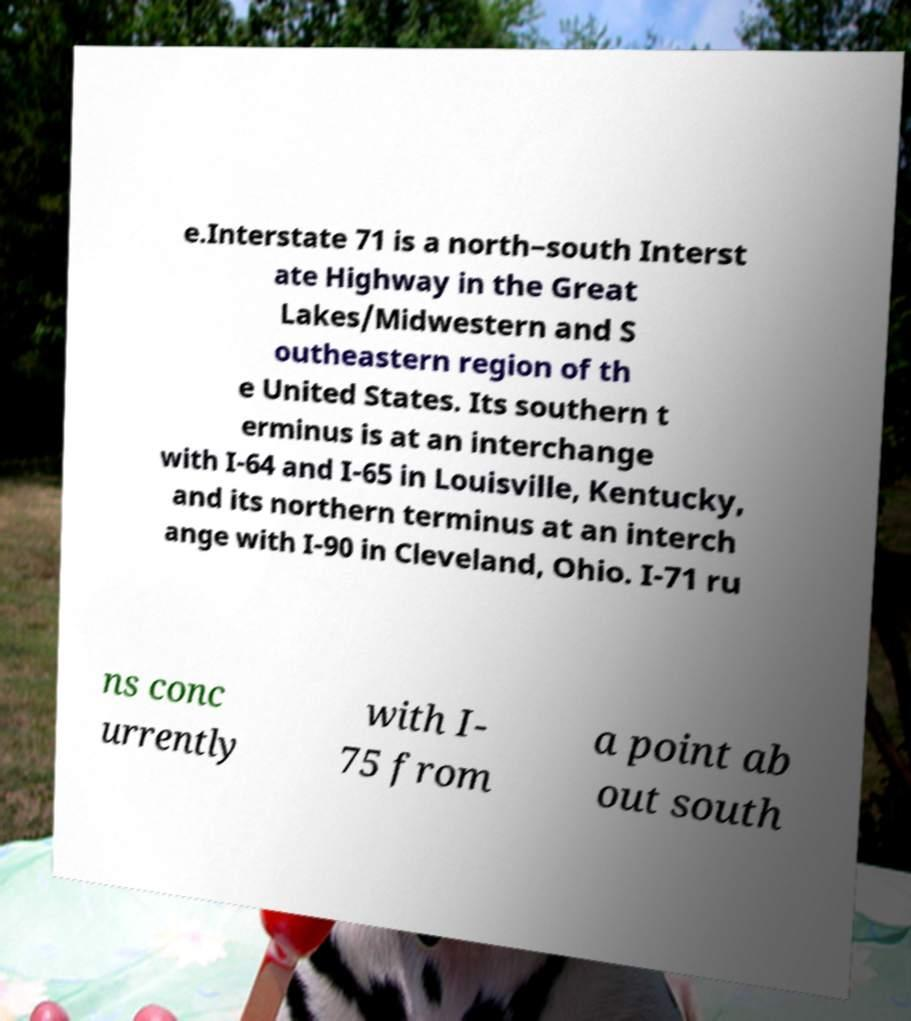There's text embedded in this image that I need extracted. Can you transcribe it verbatim? e.Interstate 71 is a north–south Interst ate Highway in the Great Lakes/Midwestern and S outheastern region of th e United States. Its southern t erminus is at an interchange with I-64 and I-65 in Louisville, Kentucky, and its northern terminus at an interch ange with I-90 in Cleveland, Ohio. I-71 ru ns conc urrently with I- 75 from a point ab out south 